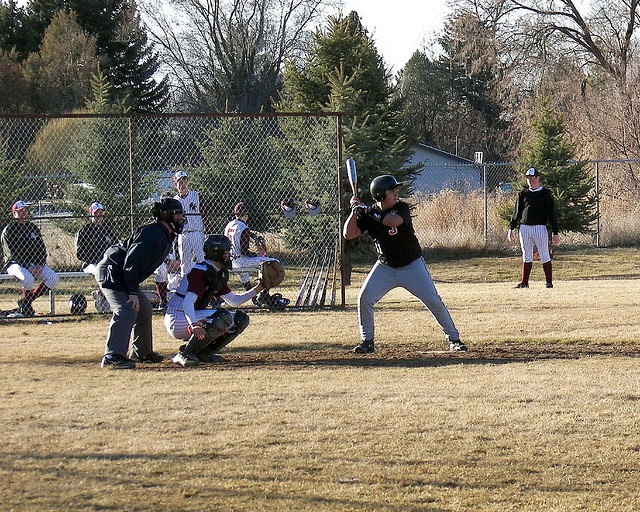Describe the objects in this image and their specific colors. I can see people in darkgray, black, gray, maroon, and ivory tones, people in darkgray, black, gray, and lightgray tones, people in darkgray, black, and gray tones, people in darkgray, black, gray, and white tones, and people in darkgray, black, and gray tones in this image. 